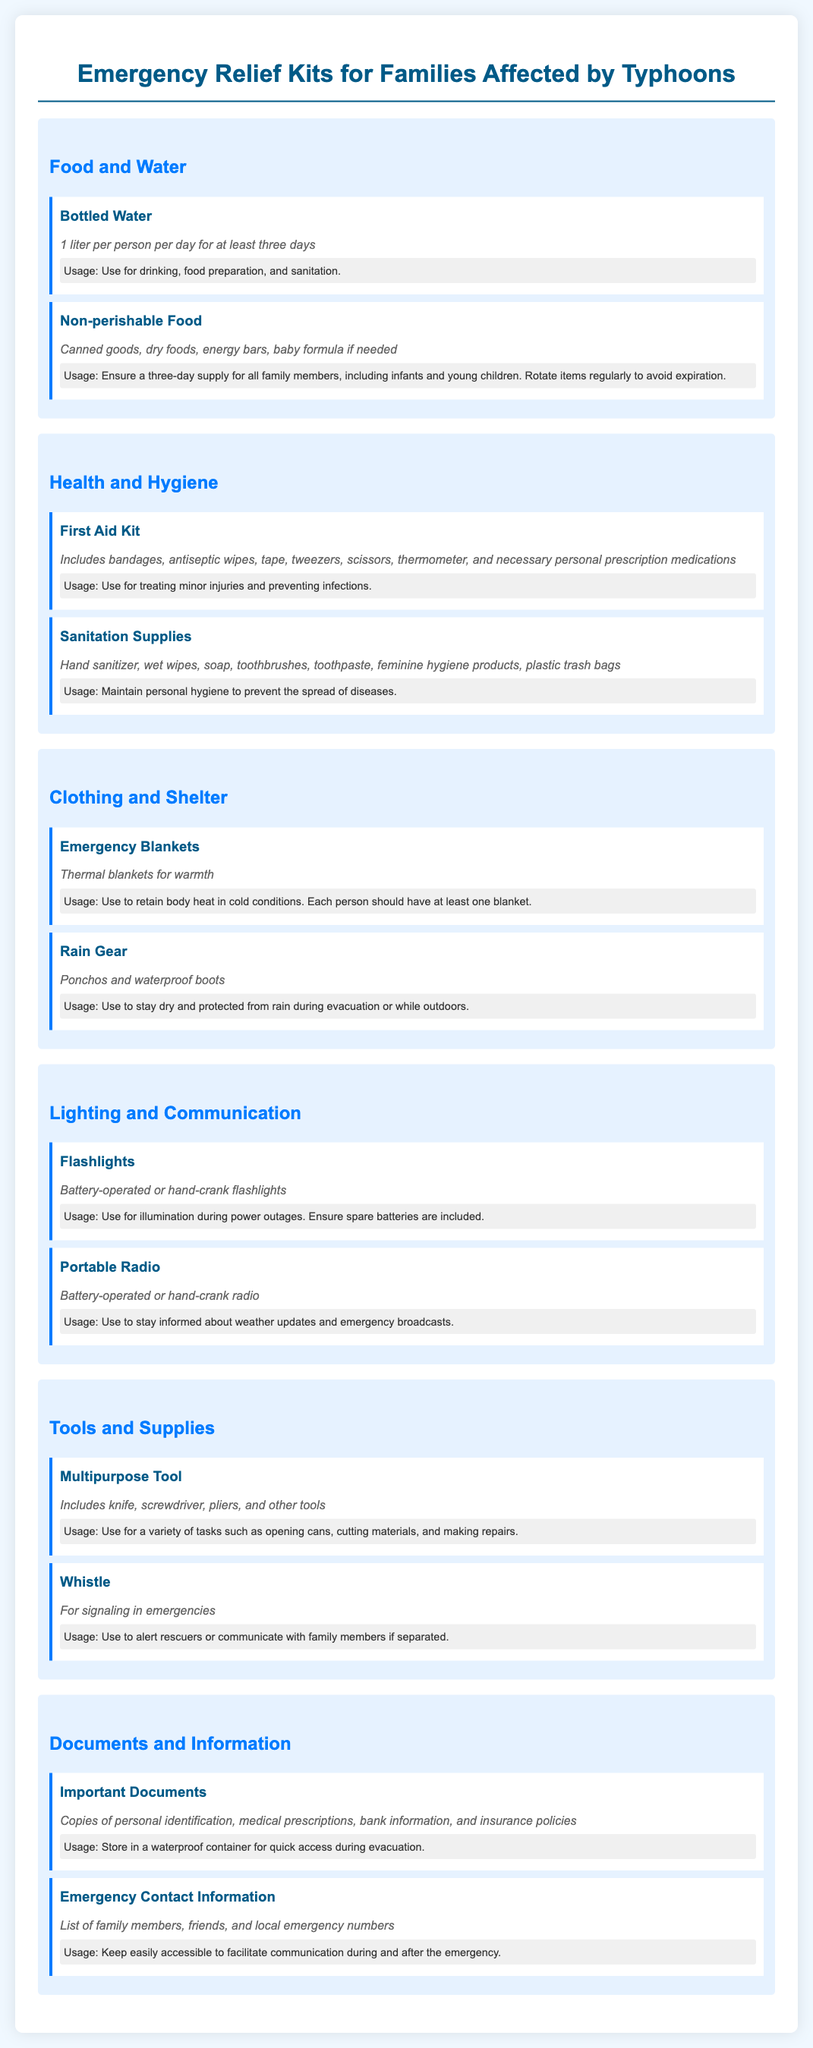what is the recommended amount of bottled water per person per day? The document states that 1 liter of bottled water is recommended per person per day for at least three days.
Answer: 1 liter which item is suggested for maintaining personal hygiene? The document lists sanitation supplies which include hand sanitizer, wet wipes, soap, and toothbrushes among others for maintaining personal hygiene.
Answer: Sanitation Supplies how many emergency blankets should each person have? According to the document, each person should have at least one emergency blanket to retain body heat in cold conditions.
Answer: At least one what is the usage of a whistle? The whistle is specified to be used for signaling in emergencies, particularly to alert rescuers or communicate with family members if separated.
Answer: Signaling in emergencies what should important documents be stored in? The document specifies that important documents should be stored in a waterproof container for quick access during evacuation.
Answer: Waterproof container what type of food items are included in the non-perishable food category? The document includes canned goods, dry foods, energy bars, and baby formula in the non-perishable food category.
Answer: Canned goods, dry foods, energy bars, baby formula which type of tool is mentioned for various tasks such as opening cans? The document mentions a multipurpose tool, which includes a knife, screwdriver, pliers, and other tools for a variety of tasks including opening cans.
Answer: Multipurpose Tool what is included in the first aid kit? The first aid kit includes bandages, antiseptic wipes, tape, tweezers, scissors, thermometer, and necessary personal prescription medications.
Answer: Bandages, antiseptic wipes, tape, tweezers, scissors, thermometer, personal prescription medications how can families stay informed about weather updates during an emergency? Families can stay informed about weather updates by using a portable radio, which can be battery-operated or hand-crank.
Answer: Portable Radio 